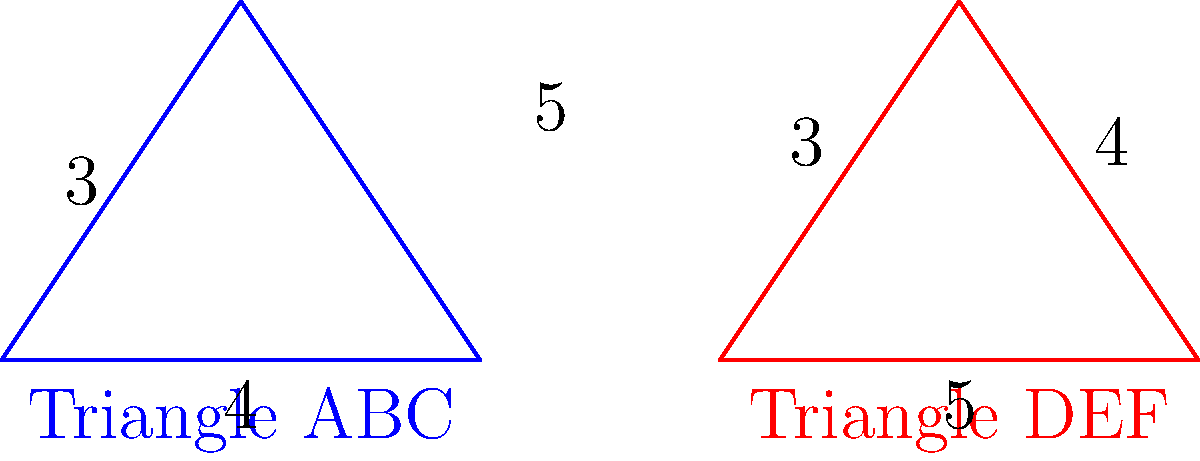Given two triangles ABC and DEF with their side lengths as shown in the figure, are these triangles congruent? If yes, state the congruence criterion used. To determine if the triangles are congruent, we need to compare their side lengths:

1. Triangle ABC:
   - Side AB = 4
   - Side BC = 5
   - Side AC = 3

2. Triangle DEF:
   - Side DE = 3
   - Side EF = 4
   - Side DF = 5

3. Comparing the side lengths:
   - AB (4) = EF (4)
   - BC (5) = DF (5)
   - AC (3) = DE (3)

4. We can see that all three sides of Triangle ABC are equal to the corresponding sides of Triangle DEF.

5. This satisfies the Side-Side-Side (SSS) congruence criterion, which states that if three sides of one triangle are equal to three sides of another triangle, then the triangles are congruent.

Therefore, Triangle ABC is congruent to Triangle DEF by the SSS congruence criterion.
Answer: Yes, SSS 